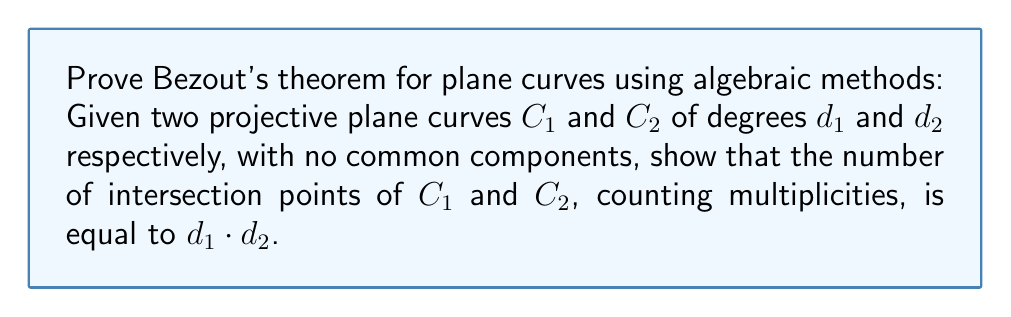Can you answer this question? To prove Bezout's theorem using algebraic methods, we'll follow these steps:

1) Let $F(x,y,z)$ and $G(x,y,z)$ be the homogeneous polynomials of degrees $d_1$ and $d_2$ defining $C_1$ and $C_2$ respectively.

2) Consider the resultant $R(y,z)$ of $F$ and $G$ with respect to $x$. This is a polynomial in $y$ and $z$ of degree $d_1d_2$.

3) The resultant $R(y,z)$ vanishes if and only if $F$ and $G$ have a common root for the given $(y,z)$.

4) By the Fundamental Theorem of Algebra, $R(y,z)$ has exactly $d_1d_2$ roots (counting multiplicity) when considered as a polynomial in $y$ with coefficients in $\mathbb{C}(z)$.

5) Each root of $R(y,z)$ corresponds to an intersection point of $C_1$ and $C_2$.

6) The multiplicity of each root of $R(y,z)$ equals the intersection multiplicity of $C_1$ and $C_2$ at the corresponding point.

7) Therefore, the total number of intersection points, counting multiplicities, is equal to the degree of $R(y,z)$, which is $d_1d_2$.

This proves Bezout's theorem for plane curves using algebraic methods.
Answer: The number of intersection points of $C_1$ and $C_2$, counting multiplicities, equals $d_1 \cdot d_2$. 